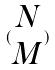<formula> <loc_0><loc_0><loc_500><loc_500>( \begin{matrix} N \\ M \end{matrix} )</formula> 